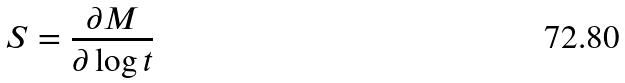Convert formula to latex. <formula><loc_0><loc_0><loc_500><loc_500>S = \frac { \partial M } { \partial \log t }</formula> 